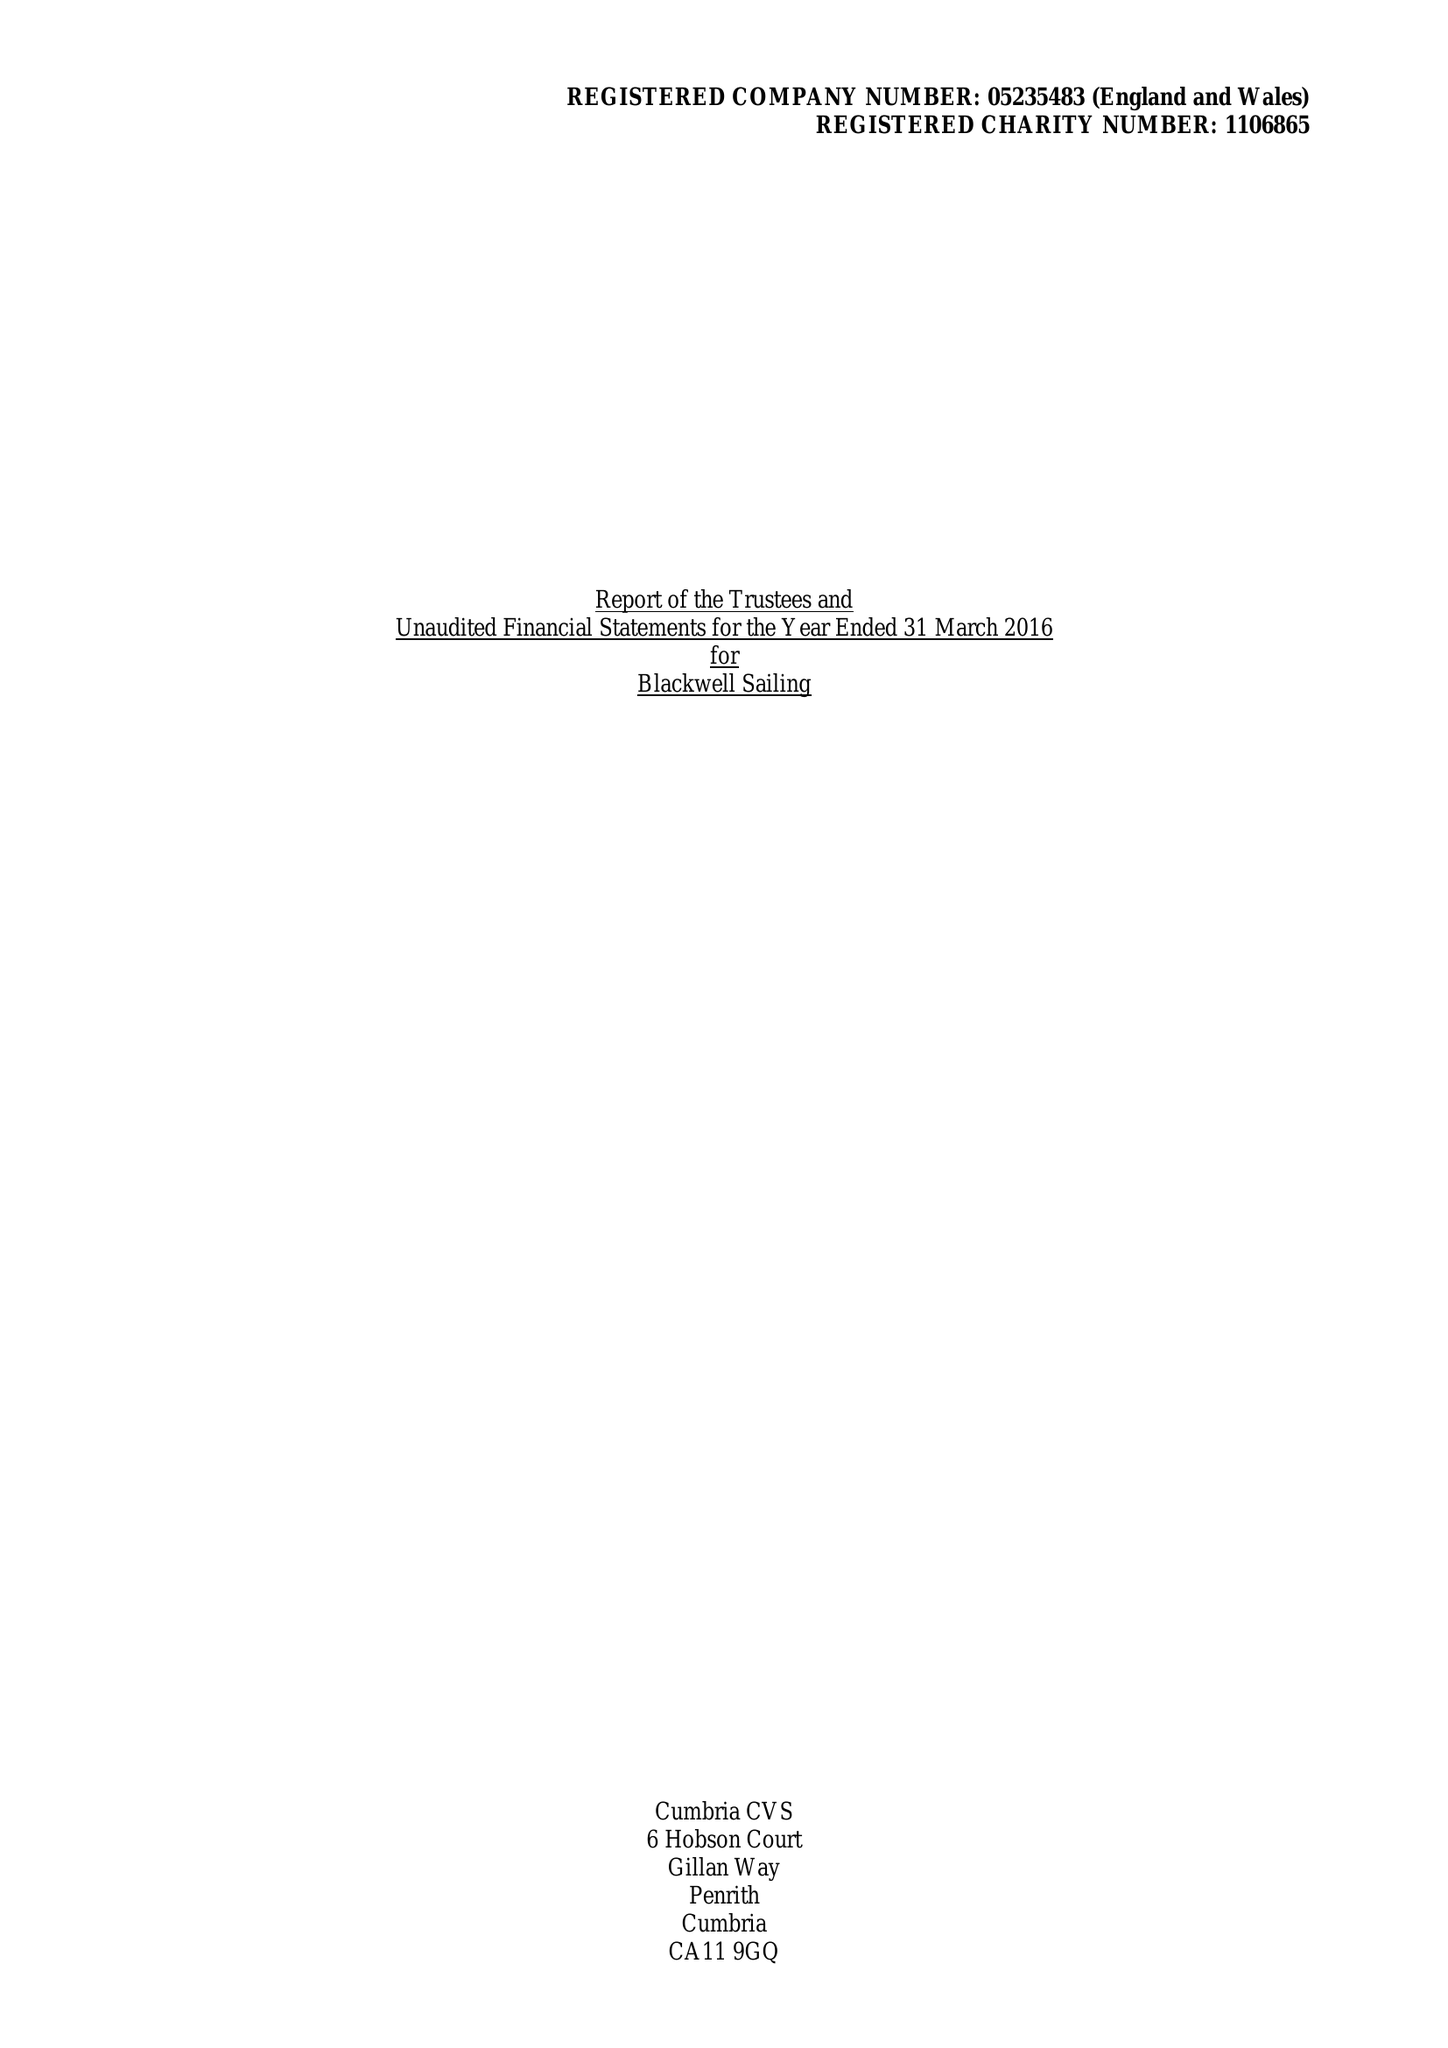What is the value for the charity_name?
Answer the question using a single word or phrase. Blackwell Sailing 